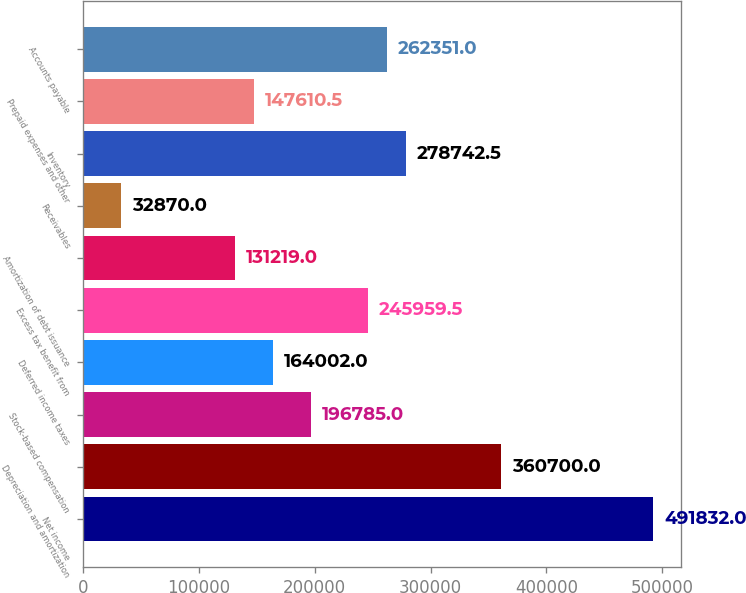Convert chart. <chart><loc_0><loc_0><loc_500><loc_500><bar_chart><fcel>Net income<fcel>Depreciation and amortization<fcel>Stock-based compensation<fcel>Deferred income taxes<fcel>Excess tax benefit from<fcel>Amortization of debt issuance<fcel>Receivables<fcel>Inventory<fcel>Prepaid expenses and other<fcel>Accounts payable<nl><fcel>491832<fcel>360700<fcel>196785<fcel>164002<fcel>245960<fcel>131219<fcel>32870<fcel>278742<fcel>147610<fcel>262351<nl></chart> 